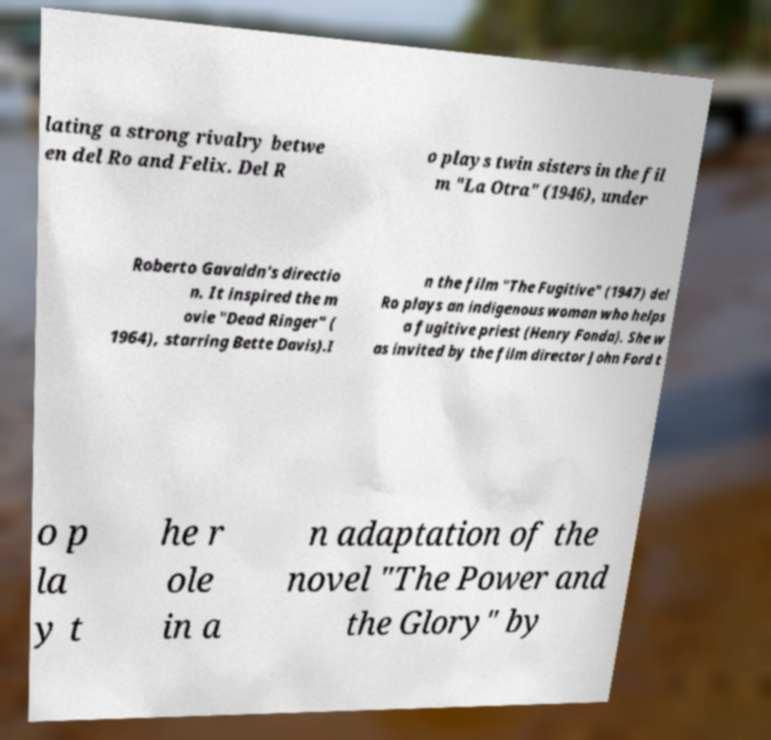For documentation purposes, I need the text within this image transcribed. Could you provide that? lating a strong rivalry betwe en del Ro and Felix. Del R o plays twin sisters in the fil m "La Otra" (1946), under Roberto Gavaldn's directio n. It inspired the m ovie "Dead Ringer" ( 1964), starring Bette Davis).I n the film "The Fugitive" (1947) del Ro plays an indigenous woman who helps a fugitive priest (Henry Fonda). She w as invited by the film director John Ford t o p la y t he r ole in a n adaptation of the novel "The Power and the Glory" by 